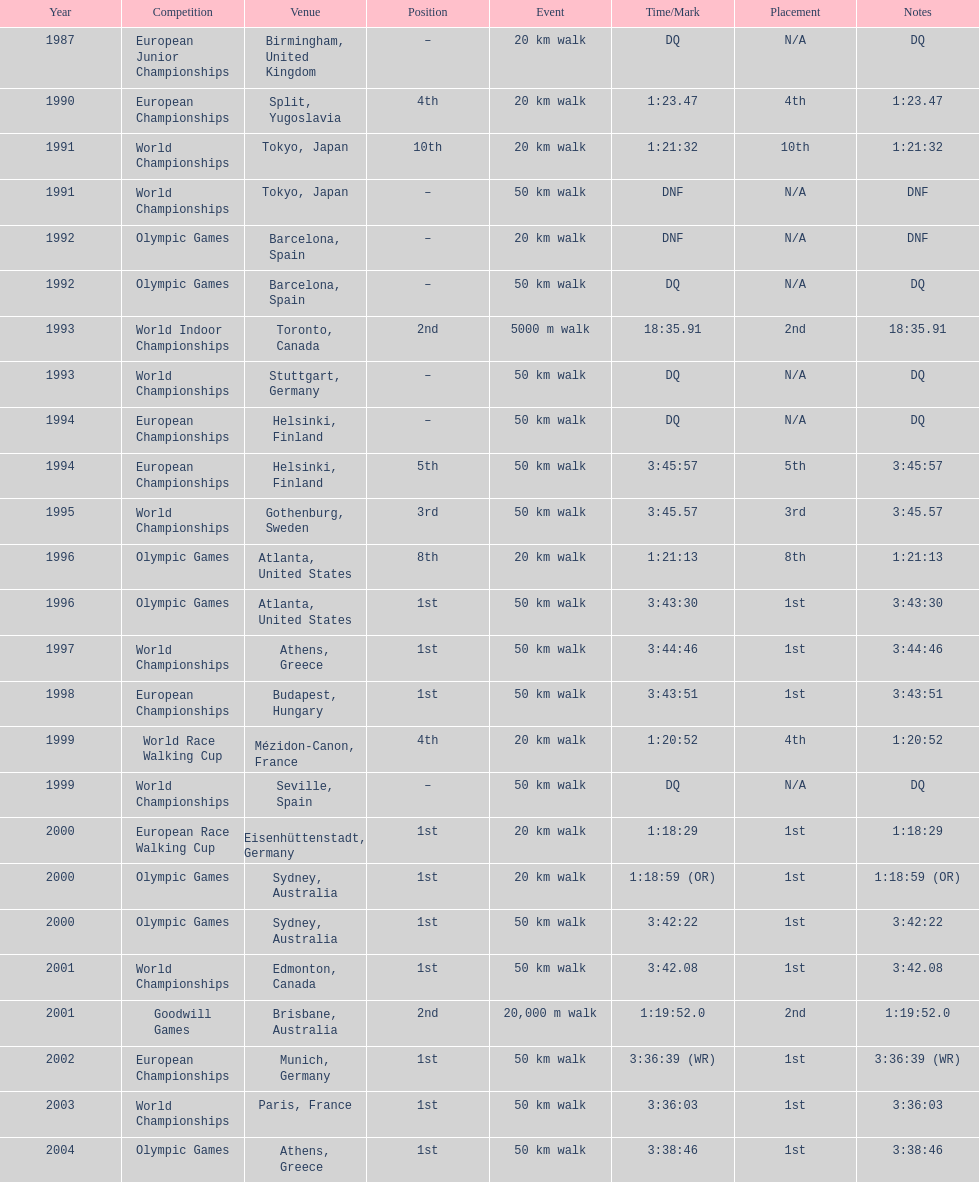How frequently was first place reported as the position? 10. 